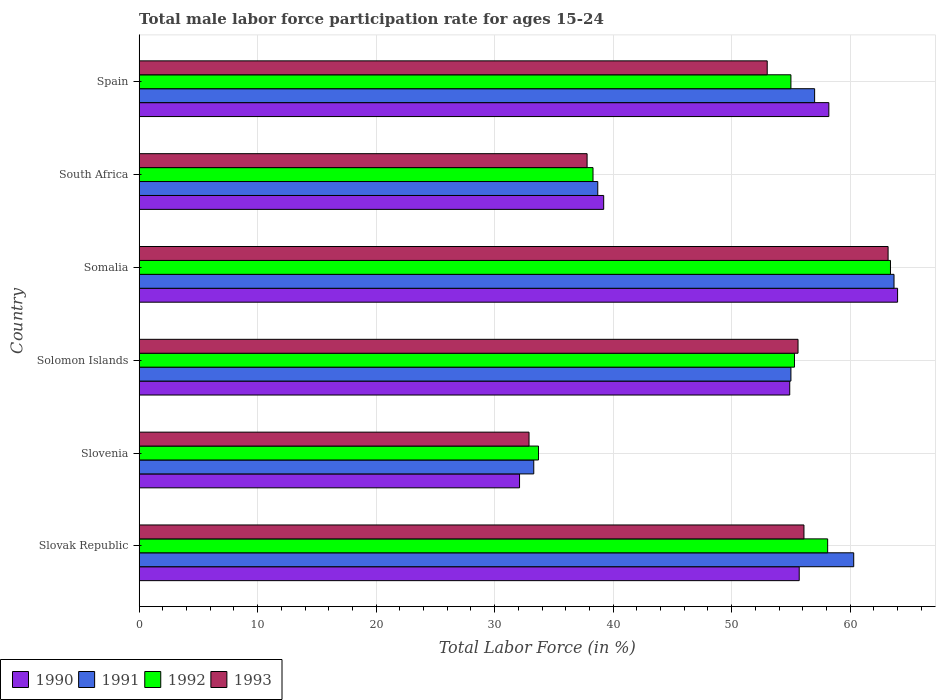How many different coloured bars are there?
Your answer should be very brief. 4. How many groups of bars are there?
Keep it short and to the point. 6. Are the number of bars per tick equal to the number of legend labels?
Give a very brief answer. Yes. Are the number of bars on each tick of the Y-axis equal?
Give a very brief answer. Yes. How many bars are there on the 2nd tick from the bottom?
Your answer should be compact. 4. What is the label of the 3rd group of bars from the top?
Your response must be concise. Somalia. What is the male labor force participation rate in 1992 in Somalia?
Your answer should be very brief. 63.4. Across all countries, what is the maximum male labor force participation rate in 1992?
Your response must be concise. 63.4. Across all countries, what is the minimum male labor force participation rate in 1992?
Provide a short and direct response. 33.7. In which country was the male labor force participation rate in 1992 maximum?
Offer a terse response. Somalia. In which country was the male labor force participation rate in 1991 minimum?
Your answer should be very brief. Slovenia. What is the total male labor force participation rate in 1993 in the graph?
Make the answer very short. 298.6. What is the difference between the male labor force participation rate in 1993 in Slovenia and the male labor force participation rate in 1992 in South Africa?
Offer a terse response. -5.4. What is the average male labor force participation rate in 1993 per country?
Offer a terse response. 49.77. What is the difference between the male labor force participation rate in 1993 and male labor force participation rate in 1991 in Slovak Republic?
Keep it short and to the point. -4.2. What is the ratio of the male labor force participation rate in 1993 in Slovak Republic to that in South Africa?
Provide a short and direct response. 1.48. Is the difference between the male labor force participation rate in 1993 in South Africa and Spain greater than the difference between the male labor force participation rate in 1991 in South Africa and Spain?
Your response must be concise. Yes. What is the difference between the highest and the second highest male labor force participation rate in 1991?
Ensure brevity in your answer.  3.4. What is the difference between the highest and the lowest male labor force participation rate in 1992?
Give a very brief answer. 29.7. In how many countries, is the male labor force participation rate in 1993 greater than the average male labor force participation rate in 1993 taken over all countries?
Your response must be concise. 4. Is it the case that in every country, the sum of the male labor force participation rate in 1990 and male labor force participation rate in 1992 is greater than the sum of male labor force participation rate in 1991 and male labor force participation rate in 1993?
Give a very brief answer. No. What does the 4th bar from the bottom in Solomon Islands represents?
Make the answer very short. 1993. Are all the bars in the graph horizontal?
Give a very brief answer. Yes. How many countries are there in the graph?
Offer a terse response. 6. What is the difference between two consecutive major ticks on the X-axis?
Your answer should be very brief. 10. Does the graph contain any zero values?
Keep it short and to the point. No. Where does the legend appear in the graph?
Offer a terse response. Bottom left. How many legend labels are there?
Provide a short and direct response. 4. How are the legend labels stacked?
Your answer should be very brief. Horizontal. What is the title of the graph?
Provide a succinct answer. Total male labor force participation rate for ages 15-24. What is the label or title of the X-axis?
Your response must be concise. Total Labor Force (in %). What is the Total Labor Force (in %) of 1990 in Slovak Republic?
Make the answer very short. 55.7. What is the Total Labor Force (in %) of 1991 in Slovak Republic?
Your answer should be compact. 60.3. What is the Total Labor Force (in %) in 1992 in Slovak Republic?
Your answer should be very brief. 58.1. What is the Total Labor Force (in %) in 1993 in Slovak Republic?
Offer a terse response. 56.1. What is the Total Labor Force (in %) in 1990 in Slovenia?
Ensure brevity in your answer.  32.1. What is the Total Labor Force (in %) in 1991 in Slovenia?
Your response must be concise. 33.3. What is the Total Labor Force (in %) of 1992 in Slovenia?
Offer a very short reply. 33.7. What is the Total Labor Force (in %) in 1993 in Slovenia?
Offer a very short reply. 32.9. What is the Total Labor Force (in %) of 1990 in Solomon Islands?
Offer a very short reply. 54.9. What is the Total Labor Force (in %) of 1991 in Solomon Islands?
Your answer should be compact. 55. What is the Total Labor Force (in %) of 1992 in Solomon Islands?
Ensure brevity in your answer.  55.3. What is the Total Labor Force (in %) of 1993 in Solomon Islands?
Your response must be concise. 55.6. What is the Total Labor Force (in %) of 1990 in Somalia?
Provide a short and direct response. 64. What is the Total Labor Force (in %) of 1991 in Somalia?
Provide a succinct answer. 63.7. What is the Total Labor Force (in %) of 1992 in Somalia?
Offer a very short reply. 63.4. What is the Total Labor Force (in %) of 1993 in Somalia?
Keep it short and to the point. 63.2. What is the Total Labor Force (in %) of 1990 in South Africa?
Your answer should be compact. 39.2. What is the Total Labor Force (in %) of 1991 in South Africa?
Provide a succinct answer. 38.7. What is the Total Labor Force (in %) of 1992 in South Africa?
Your answer should be compact. 38.3. What is the Total Labor Force (in %) in 1993 in South Africa?
Keep it short and to the point. 37.8. What is the Total Labor Force (in %) in 1990 in Spain?
Your answer should be compact. 58.2. What is the Total Labor Force (in %) of 1992 in Spain?
Offer a very short reply. 55. Across all countries, what is the maximum Total Labor Force (in %) of 1990?
Give a very brief answer. 64. Across all countries, what is the maximum Total Labor Force (in %) of 1991?
Ensure brevity in your answer.  63.7. Across all countries, what is the maximum Total Labor Force (in %) of 1992?
Offer a very short reply. 63.4. Across all countries, what is the maximum Total Labor Force (in %) of 1993?
Make the answer very short. 63.2. Across all countries, what is the minimum Total Labor Force (in %) of 1990?
Offer a terse response. 32.1. Across all countries, what is the minimum Total Labor Force (in %) in 1991?
Offer a terse response. 33.3. Across all countries, what is the minimum Total Labor Force (in %) in 1992?
Make the answer very short. 33.7. Across all countries, what is the minimum Total Labor Force (in %) in 1993?
Offer a very short reply. 32.9. What is the total Total Labor Force (in %) in 1990 in the graph?
Ensure brevity in your answer.  304.1. What is the total Total Labor Force (in %) of 1991 in the graph?
Offer a very short reply. 308. What is the total Total Labor Force (in %) in 1992 in the graph?
Make the answer very short. 303.8. What is the total Total Labor Force (in %) in 1993 in the graph?
Give a very brief answer. 298.6. What is the difference between the Total Labor Force (in %) in 1990 in Slovak Republic and that in Slovenia?
Make the answer very short. 23.6. What is the difference between the Total Labor Force (in %) in 1992 in Slovak Republic and that in Slovenia?
Make the answer very short. 24.4. What is the difference between the Total Labor Force (in %) in 1993 in Slovak Republic and that in Slovenia?
Offer a very short reply. 23.2. What is the difference between the Total Labor Force (in %) of 1991 in Slovak Republic and that in Somalia?
Give a very brief answer. -3.4. What is the difference between the Total Labor Force (in %) in 1992 in Slovak Republic and that in Somalia?
Give a very brief answer. -5.3. What is the difference between the Total Labor Force (in %) of 1993 in Slovak Republic and that in Somalia?
Make the answer very short. -7.1. What is the difference between the Total Labor Force (in %) of 1990 in Slovak Republic and that in South Africa?
Make the answer very short. 16.5. What is the difference between the Total Labor Force (in %) of 1991 in Slovak Republic and that in South Africa?
Your answer should be compact. 21.6. What is the difference between the Total Labor Force (in %) of 1992 in Slovak Republic and that in South Africa?
Keep it short and to the point. 19.8. What is the difference between the Total Labor Force (in %) of 1990 in Slovak Republic and that in Spain?
Your answer should be compact. -2.5. What is the difference between the Total Labor Force (in %) in 1991 in Slovak Republic and that in Spain?
Offer a very short reply. 3.3. What is the difference between the Total Labor Force (in %) of 1990 in Slovenia and that in Solomon Islands?
Make the answer very short. -22.8. What is the difference between the Total Labor Force (in %) of 1991 in Slovenia and that in Solomon Islands?
Give a very brief answer. -21.7. What is the difference between the Total Labor Force (in %) in 1992 in Slovenia and that in Solomon Islands?
Provide a succinct answer. -21.6. What is the difference between the Total Labor Force (in %) in 1993 in Slovenia and that in Solomon Islands?
Offer a very short reply. -22.7. What is the difference between the Total Labor Force (in %) of 1990 in Slovenia and that in Somalia?
Your response must be concise. -31.9. What is the difference between the Total Labor Force (in %) of 1991 in Slovenia and that in Somalia?
Provide a short and direct response. -30.4. What is the difference between the Total Labor Force (in %) in 1992 in Slovenia and that in Somalia?
Provide a succinct answer. -29.7. What is the difference between the Total Labor Force (in %) in 1993 in Slovenia and that in Somalia?
Ensure brevity in your answer.  -30.3. What is the difference between the Total Labor Force (in %) of 1992 in Slovenia and that in South Africa?
Provide a short and direct response. -4.6. What is the difference between the Total Labor Force (in %) in 1993 in Slovenia and that in South Africa?
Your response must be concise. -4.9. What is the difference between the Total Labor Force (in %) in 1990 in Slovenia and that in Spain?
Your response must be concise. -26.1. What is the difference between the Total Labor Force (in %) in 1991 in Slovenia and that in Spain?
Provide a short and direct response. -23.7. What is the difference between the Total Labor Force (in %) in 1992 in Slovenia and that in Spain?
Keep it short and to the point. -21.3. What is the difference between the Total Labor Force (in %) in 1993 in Slovenia and that in Spain?
Your response must be concise. -20.1. What is the difference between the Total Labor Force (in %) of 1991 in Solomon Islands and that in South Africa?
Make the answer very short. 16.3. What is the difference between the Total Labor Force (in %) of 1992 in Solomon Islands and that in South Africa?
Provide a short and direct response. 17. What is the difference between the Total Labor Force (in %) in 1990 in Solomon Islands and that in Spain?
Your response must be concise. -3.3. What is the difference between the Total Labor Force (in %) in 1992 in Solomon Islands and that in Spain?
Offer a terse response. 0.3. What is the difference between the Total Labor Force (in %) of 1990 in Somalia and that in South Africa?
Offer a very short reply. 24.8. What is the difference between the Total Labor Force (in %) in 1992 in Somalia and that in South Africa?
Your response must be concise. 25.1. What is the difference between the Total Labor Force (in %) in 1993 in Somalia and that in South Africa?
Provide a succinct answer. 25.4. What is the difference between the Total Labor Force (in %) in 1991 in Somalia and that in Spain?
Your answer should be compact. 6.7. What is the difference between the Total Labor Force (in %) in 1993 in Somalia and that in Spain?
Give a very brief answer. 10.2. What is the difference between the Total Labor Force (in %) in 1990 in South Africa and that in Spain?
Keep it short and to the point. -19. What is the difference between the Total Labor Force (in %) of 1991 in South Africa and that in Spain?
Offer a very short reply. -18.3. What is the difference between the Total Labor Force (in %) of 1992 in South Africa and that in Spain?
Provide a succinct answer. -16.7. What is the difference between the Total Labor Force (in %) in 1993 in South Africa and that in Spain?
Offer a terse response. -15.2. What is the difference between the Total Labor Force (in %) of 1990 in Slovak Republic and the Total Labor Force (in %) of 1991 in Slovenia?
Give a very brief answer. 22.4. What is the difference between the Total Labor Force (in %) of 1990 in Slovak Republic and the Total Labor Force (in %) of 1992 in Slovenia?
Offer a terse response. 22. What is the difference between the Total Labor Force (in %) in 1990 in Slovak Republic and the Total Labor Force (in %) in 1993 in Slovenia?
Offer a very short reply. 22.8. What is the difference between the Total Labor Force (in %) in 1991 in Slovak Republic and the Total Labor Force (in %) in 1992 in Slovenia?
Provide a succinct answer. 26.6. What is the difference between the Total Labor Force (in %) in 1991 in Slovak Republic and the Total Labor Force (in %) in 1993 in Slovenia?
Your response must be concise. 27.4. What is the difference between the Total Labor Force (in %) of 1992 in Slovak Republic and the Total Labor Force (in %) of 1993 in Slovenia?
Provide a succinct answer. 25.2. What is the difference between the Total Labor Force (in %) of 1990 in Slovak Republic and the Total Labor Force (in %) of 1991 in Solomon Islands?
Provide a short and direct response. 0.7. What is the difference between the Total Labor Force (in %) of 1990 in Slovak Republic and the Total Labor Force (in %) of 1992 in Solomon Islands?
Provide a succinct answer. 0.4. What is the difference between the Total Labor Force (in %) of 1991 in Slovak Republic and the Total Labor Force (in %) of 1993 in Solomon Islands?
Your answer should be very brief. 4.7. What is the difference between the Total Labor Force (in %) of 1992 in Slovak Republic and the Total Labor Force (in %) of 1993 in Solomon Islands?
Make the answer very short. 2.5. What is the difference between the Total Labor Force (in %) in 1990 in Slovak Republic and the Total Labor Force (in %) in 1991 in Somalia?
Provide a succinct answer. -8. What is the difference between the Total Labor Force (in %) of 1991 in Slovak Republic and the Total Labor Force (in %) of 1992 in Somalia?
Offer a very short reply. -3.1. What is the difference between the Total Labor Force (in %) of 1990 in Slovak Republic and the Total Labor Force (in %) of 1992 in South Africa?
Offer a very short reply. 17.4. What is the difference between the Total Labor Force (in %) in 1990 in Slovak Republic and the Total Labor Force (in %) in 1993 in South Africa?
Your answer should be compact. 17.9. What is the difference between the Total Labor Force (in %) of 1991 in Slovak Republic and the Total Labor Force (in %) of 1992 in South Africa?
Your answer should be compact. 22. What is the difference between the Total Labor Force (in %) of 1992 in Slovak Republic and the Total Labor Force (in %) of 1993 in South Africa?
Ensure brevity in your answer.  20.3. What is the difference between the Total Labor Force (in %) of 1990 in Slovak Republic and the Total Labor Force (in %) of 1991 in Spain?
Provide a short and direct response. -1.3. What is the difference between the Total Labor Force (in %) in 1990 in Slovenia and the Total Labor Force (in %) in 1991 in Solomon Islands?
Offer a very short reply. -22.9. What is the difference between the Total Labor Force (in %) of 1990 in Slovenia and the Total Labor Force (in %) of 1992 in Solomon Islands?
Keep it short and to the point. -23.2. What is the difference between the Total Labor Force (in %) of 1990 in Slovenia and the Total Labor Force (in %) of 1993 in Solomon Islands?
Give a very brief answer. -23.5. What is the difference between the Total Labor Force (in %) of 1991 in Slovenia and the Total Labor Force (in %) of 1992 in Solomon Islands?
Your answer should be compact. -22. What is the difference between the Total Labor Force (in %) of 1991 in Slovenia and the Total Labor Force (in %) of 1993 in Solomon Islands?
Offer a terse response. -22.3. What is the difference between the Total Labor Force (in %) in 1992 in Slovenia and the Total Labor Force (in %) in 1993 in Solomon Islands?
Make the answer very short. -21.9. What is the difference between the Total Labor Force (in %) of 1990 in Slovenia and the Total Labor Force (in %) of 1991 in Somalia?
Your answer should be very brief. -31.6. What is the difference between the Total Labor Force (in %) in 1990 in Slovenia and the Total Labor Force (in %) in 1992 in Somalia?
Provide a succinct answer. -31.3. What is the difference between the Total Labor Force (in %) of 1990 in Slovenia and the Total Labor Force (in %) of 1993 in Somalia?
Offer a very short reply. -31.1. What is the difference between the Total Labor Force (in %) in 1991 in Slovenia and the Total Labor Force (in %) in 1992 in Somalia?
Provide a short and direct response. -30.1. What is the difference between the Total Labor Force (in %) in 1991 in Slovenia and the Total Labor Force (in %) in 1993 in Somalia?
Your answer should be very brief. -29.9. What is the difference between the Total Labor Force (in %) in 1992 in Slovenia and the Total Labor Force (in %) in 1993 in Somalia?
Your answer should be compact. -29.5. What is the difference between the Total Labor Force (in %) in 1990 in Slovenia and the Total Labor Force (in %) in 1991 in South Africa?
Offer a very short reply. -6.6. What is the difference between the Total Labor Force (in %) of 1990 in Slovenia and the Total Labor Force (in %) of 1993 in South Africa?
Make the answer very short. -5.7. What is the difference between the Total Labor Force (in %) in 1991 in Slovenia and the Total Labor Force (in %) in 1992 in South Africa?
Make the answer very short. -5. What is the difference between the Total Labor Force (in %) in 1990 in Slovenia and the Total Labor Force (in %) in 1991 in Spain?
Your answer should be compact. -24.9. What is the difference between the Total Labor Force (in %) of 1990 in Slovenia and the Total Labor Force (in %) of 1992 in Spain?
Make the answer very short. -22.9. What is the difference between the Total Labor Force (in %) in 1990 in Slovenia and the Total Labor Force (in %) in 1993 in Spain?
Keep it short and to the point. -20.9. What is the difference between the Total Labor Force (in %) in 1991 in Slovenia and the Total Labor Force (in %) in 1992 in Spain?
Your response must be concise. -21.7. What is the difference between the Total Labor Force (in %) of 1991 in Slovenia and the Total Labor Force (in %) of 1993 in Spain?
Provide a short and direct response. -19.7. What is the difference between the Total Labor Force (in %) in 1992 in Slovenia and the Total Labor Force (in %) in 1993 in Spain?
Give a very brief answer. -19.3. What is the difference between the Total Labor Force (in %) in 1990 in Solomon Islands and the Total Labor Force (in %) in 1991 in Somalia?
Make the answer very short. -8.8. What is the difference between the Total Labor Force (in %) in 1990 in Solomon Islands and the Total Labor Force (in %) in 1991 in South Africa?
Ensure brevity in your answer.  16.2. What is the difference between the Total Labor Force (in %) in 1990 in Solomon Islands and the Total Labor Force (in %) in 1993 in South Africa?
Ensure brevity in your answer.  17.1. What is the difference between the Total Labor Force (in %) of 1990 in Solomon Islands and the Total Labor Force (in %) of 1992 in Spain?
Keep it short and to the point. -0.1. What is the difference between the Total Labor Force (in %) of 1990 in Solomon Islands and the Total Labor Force (in %) of 1993 in Spain?
Your answer should be very brief. 1.9. What is the difference between the Total Labor Force (in %) of 1991 in Solomon Islands and the Total Labor Force (in %) of 1992 in Spain?
Your answer should be very brief. 0. What is the difference between the Total Labor Force (in %) in 1990 in Somalia and the Total Labor Force (in %) in 1991 in South Africa?
Offer a terse response. 25.3. What is the difference between the Total Labor Force (in %) of 1990 in Somalia and the Total Labor Force (in %) of 1992 in South Africa?
Ensure brevity in your answer.  25.7. What is the difference between the Total Labor Force (in %) in 1990 in Somalia and the Total Labor Force (in %) in 1993 in South Africa?
Offer a very short reply. 26.2. What is the difference between the Total Labor Force (in %) of 1991 in Somalia and the Total Labor Force (in %) of 1992 in South Africa?
Ensure brevity in your answer.  25.4. What is the difference between the Total Labor Force (in %) of 1991 in Somalia and the Total Labor Force (in %) of 1993 in South Africa?
Make the answer very short. 25.9. What is the difference between the Total Labor Force (in %) of 1992 in Somalia and the Total Labor Force (in %) of 1993 in South Africa?
Provide a short and direct response. 25.6. What is the difference between the Total Labor Force (in %) of 1990 in Somalia and the Total Labor Force (in %) of 1991 in Spain?
Make the answer very short. 7. What is the difference between the Total Labor Force (in %) in 1990 in Somalia and the Total Labor Force (in %) in 1993 in Spain?
Offer a very short reply. 11. What is the difference between the Total Labor Force (in %) in 1990 in South Africa and the Total Labor Force (in %) in 1991 in Spain?
Ensure brevity in your answer.  -17.8. What is the difference between the Total Labor Force (in %) of 1990 in South Africa and the Total Labor Force (in %) of 1992 in Spain?
Provide a short and direct response. -15.8. What is the difference between the Total Labor Force (in %) in 1991 in South Africa and the Total Labor Force (in %) in 1992 in Spain?
Your answer should be compact. -16.3. What is the difference between the Total Labor Force (in %) of 1991 in South Africa and the Total Labor Force (in %) of 1993 in Spain?
Keep it short and to the point. -14.3. What is the difference between the Total Labor Force (in %) in 1992 in South Africa and the Total Labor Force (in %) in 1993 in Spain?
Give a very brief answer. -14.7. What is the average Total Labor Force (in %) in 1990 per country?
Keep it short and to the point. 50.68. What is the average Total Labor Force (in %) of 1991 per country?
Offer a terse response. 51.33. What is the average Total Labor Force (in %) of 1992 per country?
Your answer should be very brief. 50.63. What is the average Total Labor Force (in %) in 1993 per country?
Provide a short and direct response. 49.77. What is the difference between the Total Labor Force (in %) in 1990 and Total Labor Force (in %) in 1991 in Slovak Republic?
Your answer should be very brief. -4.6. What is the difference between the Total Labor Force (in %) in 1992 and Total Labor Force (in %) in 1993 in Slovak Republic?
Your answer should be compact. 2. What is the difference between the Total Labor Force (in %) in 1990 and Total Labor Force (in %) in 1991 in Slovenia?
Ensure brevity in your answer.  -1.2. What is the difference between the Total Labor Force (in %) in 1991 and Total Labor Force (in %) in 1993 in Slovenia?
Make the answer very short. 0.4. What is the difference between the Total Labor Force (in %) in 1990 and Total Labor Force (in %) in 1993 in Solomon Islands?
Offer a very short reply. -0.7. What is the difference between the Total Labor Force (in %) in 1991 and Total Labor Force (in %) in 1992 in Solomon Islands?
Your response must be concise. -0.3. What is the difference between the Total Labor Force (in %) in 1991 and Total Labor Force (in %) in 1993 in Solomon Islands?
Ensure brevity in your answer.  -0.6. What is the difference between the Total Labor Force (in %) of 1992 and Total Labor Force (in %) of 1993 in Solomon Islands?
Make the answer very short. -0.3. What is the difference between the Total Labor Force (in %) in 1990 and Total Labor Force (in %) in 1991 in Somalia?
Your response must be concise. 0.3. What is the difference between the Total Labor Force (in %) in 1990 and Total Labor Force (in %) in 1993 in Somalia?
Your answer should be very brief. 0.8. What is the difference between the Total Labor Force (in %) of 1991 and Total Labor Force (in %) of 1992 in Somalia?
Give a very brief answer. 0.3. What is the difference between the Total Labor Force (in %) of 1992 and Total Labor Force (in %) of 1993 in Somalia?
Give a very brief answer. 0.2. What is the difference between the Total Labor Force (in %) of 1990 and Total Labor Force (in %) of 1992 in South Africa?
Offer a terse response. 0.9. What is the difference between the Total Labor Force (in %) of 1990 and Total Labor Force (in %) of 1993 in South Africa?
Provide a succinct answer. 1.4. What is the difference between the Total Labor Force (in %) in 1990 and Total Labor Force (in %) in 1992 in Spain?
Provide a short and direct response. 3.2. What is the difference between the Total Labor Force (in %) of 1990 and Total Labor Force (in %) of 1993 in Spain?
Ensure brevity in your answer.  5.2. What is the difference between the Total Labor Force (in %) of 1992 and Total Labor Force (in %) of 1993 in Spain?
Provide a short and direct response. 2. What is the ratio of the Total Labor Force (in %) of 1990 in Slovak Republic to that in Slovenia?
Keep it short and to the point. 1.74. What is the ratio of the Total Labor Force (in %) in 1991 in Slovak Republic to that in Slovenia?
Give a very brief answer. 1.81. What is the ratio of the Total Labor Force (in %) of 1992 in Slovak Republic to that in Slovenia?
Your answer should be compact. 1.72. What is the ratio of the Total Labor Force (in %) in 1993 in Slovak Republic to that in Slovenia?
Your response must be concise. 1.71. What is the ratio of the Total Labor Force (in %) of 1990 in Slovak Republic to that in Solomon Islands?
Your answer should be very brief. 1.01. What is the ratio of the Total Labor Force (in %) of 1991 in Slovak Republic to that in Solomon Islands?
Your response must be concise. 1.1. What is the ratio of the Total Labor Force (in %) of 1992 in Slovak Republic to that in Solomon Islands?
Make the answer very short. 1.05. What is the ratio of the Total Labor Force (in %) of 1993 in Slovak Republic to that in Solomon Islands?
Offer a very short reply. 1.01. What is the ratio of the Total Labor Force (in %) of 1990 in Slovak Republic to that in Somalia?
Offer a terse response. 0.87. What is the ratio of the Total Labor Force (in %) of 1991 in Slovak Republic to that in Somalia?
Make the answer very short. 0.95. What is the ratio of the Total Labor Force (in %) in 1992 in Slovak Republic to that in Somalia?
Provide a succinct answer. 0.92. What is the ratio of the Total Labor Force (in %) of 1993 in Slovak Republic to that in Somalia?
Ensure brevity in your answer.  0.89. What is the ratio of the Total Labor Force (in %) of 1990 in Slovak Republic to that in South Africa?
Offer a terse response. 1.42. What is the ratio of the Total Labor Force (in %) in 1991 in Slovak Republic to that in South Africa?
Keep it short and to the point. 1.56. What is the ratio of the Total Labor Force (in %) in 1992 in Slovak Republic to that in South Africa?
Ensure brevity in your answer.  1.52. What is the ratio of the Total Labor Force (in %) in 1993 in Slovak Republic to that in South Africa?
Your response must be concise. 1.48. What is the ratio of the Total Labor Force (in %) of 1991 in Slovak Republic to that in Spain?
Provide a succinct answer. 1.06. What is the ratio of the Total Labor Force (in %) of 1992 in Slovak Republic to that in Spain?
Offer a very short reply. 1.06. What is the ratio of the Total Labor Force (in %) in 1993 in Slovak Republic to that in Spain?
Provide a succinct answer. 1.06. What is the ratio of the Total Labor Force (in %) of 1990 in Slovenia to that in Solomon Islands?
Make the answer very short. 0.58. What is the ratio of the Total Labor Force (in %) in 1991 in Slovenia to that in Solomon Islands?
Provide a short and direct response. 0.61. What is the ratio of the Total Labor Force (in %) in 1992 in Slovenia to that in Solomon Islands?
Provide a short and direct response. 0.61. What is the ratio of the Total Labor Force (in %) of 1993 in Slovenia to that in Solomon Islands?
Your answer should be compact. 0.59. What is the ratio of the Total Labor Force (in %) of 1990 in Slovenia to that in Somalia?
Provide a short and direct response. 0.5. What is the ratio of the Total Labor Force (in %) in 1991 in Slovenia to that in Somalia?
Offer a terse response. 0.52. What is the ratio of the Total Labor Force (in %) in 1992 in Slovenia to that in Somalia?
Ensure brevity in your answer.  0.53. What is the ratio of the Total Labor Force (in %) of 1993 in Slovenia to that in Somalia?
Offer a terse response. 0.52. What is the ratio of the Total Labor Force (in %) in 1990 in Slovenia to that in South Africa?
Ensure brevity in your answer.  0.82. What is the ratio of the Total Labor Force (in %) in 1991 in Slovenia to that in South Africa?
Ensure brevity in your answer.  0.86. What is the ratio of the Total Labor Force (in %) of 1992 in Slovenia to that in South Africa?
Provide a succinct answer. 0.88. What is the ratio of the Total Labor Force (in %) of 1993 in Slovenia to that in South Africa?
Provide a short and direct response. 0.87. What is the ratio of the Total Labor Force (in %) in 1990 in Slovenia to that in Spain?
Your answer should be very brief. 0.55. What is the ratio of the Total Labor Force (in %) of 1991 in Slovenia to that in Spain?
Your answer should be compact. 0.58. What is the ratio of the Total Labor Force (in %) in 1992 in Slovenia to that in Spain?
Your response must be concise. 0.61. What is the ratio of the Total Labor Force (in %) in 1993 in Slovenia to that in Spain?
Give a very brief answer. 0.62. What is the ratio of the Total Labor Force (in %) of 1990 in Solomon Islands to that in Somalia?
Make the answer very short. 0.86. What is the ratio of the Total Labor Force (in %) of 1991 in Solomon Islands to that in Somalia?
Keep it short and to the point. 0.86. What is the ratio of the Total Labor Force (in %) in 1992 in Solomon Islands to that in Somalia?
Your answer should be very brief. 0.87. What is the ratio of the Total Labor Force (in %) of 1993 in Solomon Islands to that in Somalia?
Ensure brevity in your answer.  0.88. What is the ratio of the Total Labor Force (in %) in 1990 in Solomon Islands to that in South Africa?
Your answer should be very brief. 1.4. What is the ratio of the Total Labor Force (in %) in 1991 in Solomon Islands to that in South Africa?
Your answer should be compact. 1.42. What is the ratio of the Total Labor Force (in %) in 1992 in Solomon Islands to that in South Africa?
Offer a very short reply. 1.44. What is the ratio of the Total Labor Force (in %) of 1993 in Solomon Islands to that in South Africa?
Your answer should be compact. 1.47. What is the ratio of the Total Labor Force (in %) of 1990 in Solomon Islands to that in Spain?
Make the answer very short. 0.94. What is the ratio of the Total Labor Force (in %) of 1991 in Solomon Islands to that in Spain?
Your answer should be very brief. 0.96. What is the ratio of the Total Labor Force (in %) in 1993 in Solomon Islands to that in Spain?
Your answer should be very brief. 1.05. What is the ratio of the Total Labor Force (in %) of 1990 in Somalia to that in South Africa?
Make the answer very short. 1.63. What is the ratio of the Total Labor Force (in %) of 1991 in Somalia to that in South Africa?
Keep it short and to the point. 1.65. What is the ratio of the Total Labor Force (in %) in 1992 in Somalia to that in South Africa?
Offer a very short reply. 1.66. What is the ratio of the Total Labor Force (in %) in 1993 in Somalia to that in South Africa?
Give a very brief answer. 1.67. What is the ratio of the Total Labor Force (in %) in 1990 in Somalia to that in Spain?
Your answer should be very brief. 1.1. What is the ratio of the Total Labor Force (in %) of 1991 in Somalia to that in Spain?
Offer a very short reply. 1.12. What is the ratio of the Total Labor Force (in %) of 1992 in Somalia to that in Spain?
Provide a succinct answer. 1.15. What is the ratio of the Total Labor Force (in %) of 1993 in Somalia to that in Spain?
Provide a succinct answer. 1.19. What is the ratio of the Total Labor Force (in %) in 1990 in South Africa to that in Spain?
Ensure brevity in your answer.  0.67. What is the ratio of the Total Labor Force (in %) of 1991 in South Africa to that in Spain?
Make the answer very short. 0.68. What is the ratio of the Total Labor Force (in %) of 1992 in South Africa to that in Spain?
Your answer should be compact. 0.7. What is the ratio of the Total Labor Force (in %) in 1993 in South Africa to that in Spain?
Offer a very short reply. 0.71. What is the difference between the highest and the second highest Total Labor Force (in %) in 1990?
Keep it short and to the point. 5.8. What is the difference between the highest and the second highest Total Labor Force (in %) in 1992?
Your answer should be compact. 5.3. What is the difference between the highest and the second highest Total Labor Force (in %) in 1993?
Provide a succinct answer. 7.1. What is the difference between the highest and the lowest Total Labor Force (in %) in 1990?
Provide a short and direct response. 31.9. What is the difference between the highest and the lowest Total Labor Force (in %) of 1991?
Provide a succinct answer. 30.4. What is the difference between the highest and the lowest Total Labor Force (in %) in 1992?
Give a very brief answer. 29.7. What is the difference between the highest and the lowest Total Labor Force (in %) in 1993?
Offer a terse response. 30.3. 